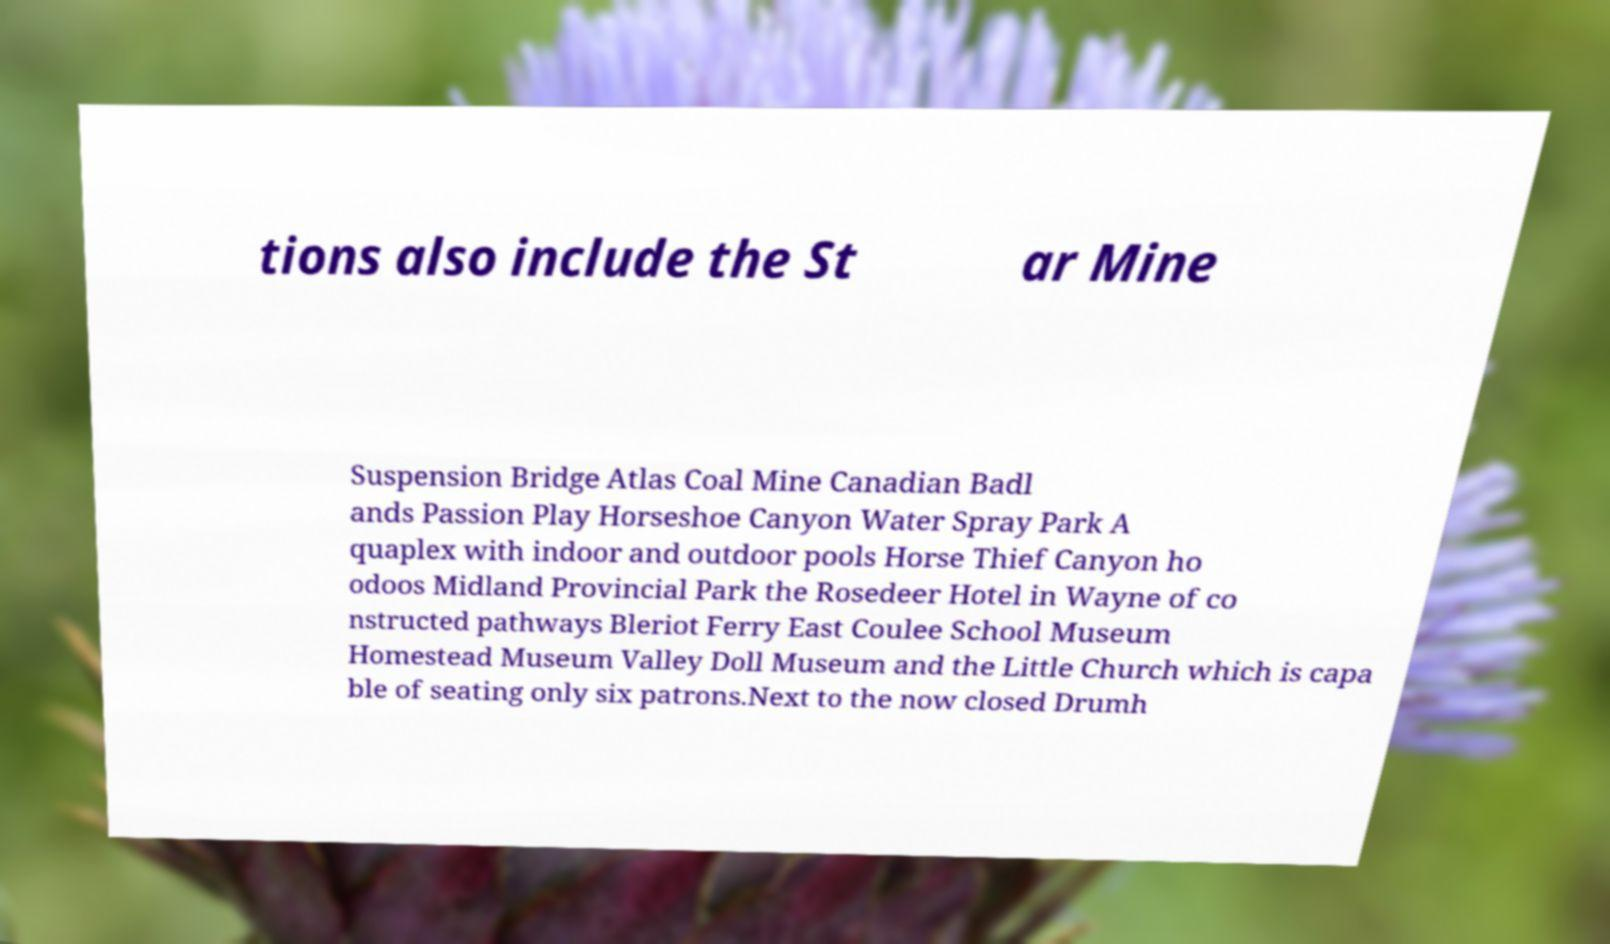For documentation purposes, I need the text within this image transcribed. Could you provide that? tions also include the St ar Mine Suspension Bridge Atlas Coal Mine Canadian Badl ands Passion Play Horseshoe Canyon Water Spray Park A quaplex with indoor and outdoor pools Horse Thief Canyon ho odoos Midland Provincial Park the Rosedeer Hotel in Wayne of co nstructed pathways Bleriot Ferry East Coulee School Museum Homestead Museum Valley Doll Museum and the Little Church which is capa ble of seating only six patrons.Next to the now closed Drumh 